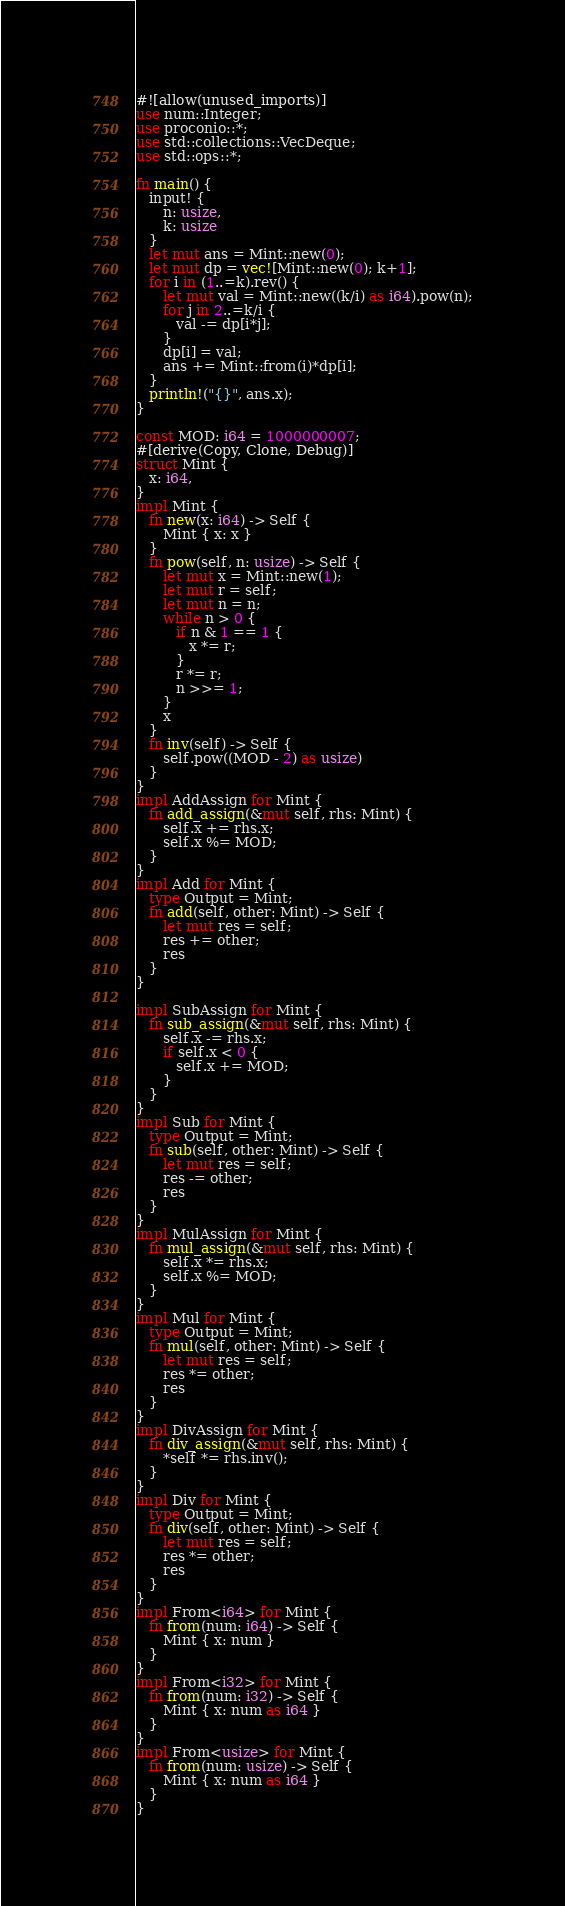<code> <loc_0><loc_0><loc_500><loc_500><_Rust_>#![allow(unused_imports)]
use num::Integer;
use proconio::*;
use std::collections::VecDeque;
use std::ops::*;

fn main() {
   input! {
      n: usize,
      k: usize
   }
   let mut ans = Mint::new(0);
   let mut dp = vec![Mint::new(0); k+1];
   for i in (1..=k).rev() {
      let mut val = Mint::new((k/i) as i64).pow(n);
      for j in 2..=k/i {
         val -= dp[i*j];
      }
      dp[i] = val;
      ans += Mint::from(i)*dp[i];
   }
   println!("{}", ans.x);
}

const MOD: i64 = 1000000007;
#[derive(Copy, Clone, Debug)]
struct Mint {
   x: i64,
}
impl Mint {
   fn new(x: i64) -> Self {
      Mint { x: x }
   }
   fn pow(self, n: usize) -> Self {
      let mut x = Mint::new(1);
      let mut r = self;
      let mut n = n;
      while n > 0 {
         if n & 1 == 1 {
            x *= r;
         }
         r *= r;
         n >>= 1;
      }
      x
   }
   fn inv(self) -> Self {
      self.pow((MOD - 2) as usize)
   }
}
impl AddAssign for Mint {
   fn add_assign(&mut self, rhs: Mint) {
      self.x += rhs.x;
      self.x %= MOD;
   }
}
impl Add for Mint {
   type Output = Mint;
   fn add(self, other: Mint) -> Self {
      let mut res = self;
      res += other;
      res
   }
}

impl SubAssign for Mint {
   fn sub_assign(&mut self, rhs: Mint) {
      self.x -= rhs.x;
      if self.x < 0 {
         self.x += MOD;
      }
   }
}
impl Sub for Mint {
   type Output = Mint;
   fn sub(self, other: Mint) -> Self {
      let mut res = self;
      res -= other;
      res
   }
}
impl MulAssign for Mint {
   fn mul_assign(&mut self, rhs: Mint) {
      self.x *= rhs.x;
      self.x %= MOD;
   }
}
impl Mul for Mint {
   type Output = Mint;
   fn mul(self, other: Mint) -> Self {
      let mut res = self;
      res *= other;
      res
   }
}
impl DivAssign for Mint {
   fn div_assign(&mut self, rhs: Mint) {
      *self *= rhs.inv();
   }
}
impl Div for Mint {
   type Output = Mint;
   fn div(self, other: Mint) -> Self {
      let mut res = self;
      res *= other;
      res
   }
}
impl From<i64> for Mint {
   fn from(num: i64) -> Self {
      Mint { x: num }
   }
}
impl From<i32> for Mint {
   fn from(num: i32) -> Self {
      Mint { x: num as i64 }
   }
}
impl From<usize> for Mint {
   fn from(num: usize) -> Self {
      Mint { x: num as i64 }
   }
}
</code> 